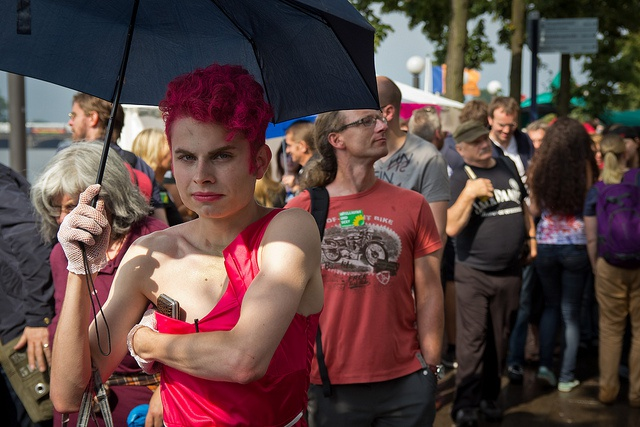Describe the objects in this image and their specific colors. I can see people in black, maroon, gray, and ivory tones, umbrella in black, gray, and maroon tones, people in black, maroon, and brown tones, people in black, gray, and maroon tones, and people in black and gray tones in this image. 